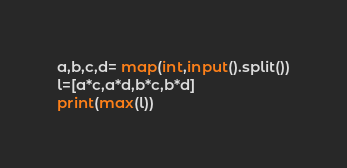<code> <loc_0><loc_0><loc_500><loc_500><_Python_>a,b,c,d= map(int,input().split())
l=[a*c,a*d,b*c,b*d]
print(max(l))</code> 